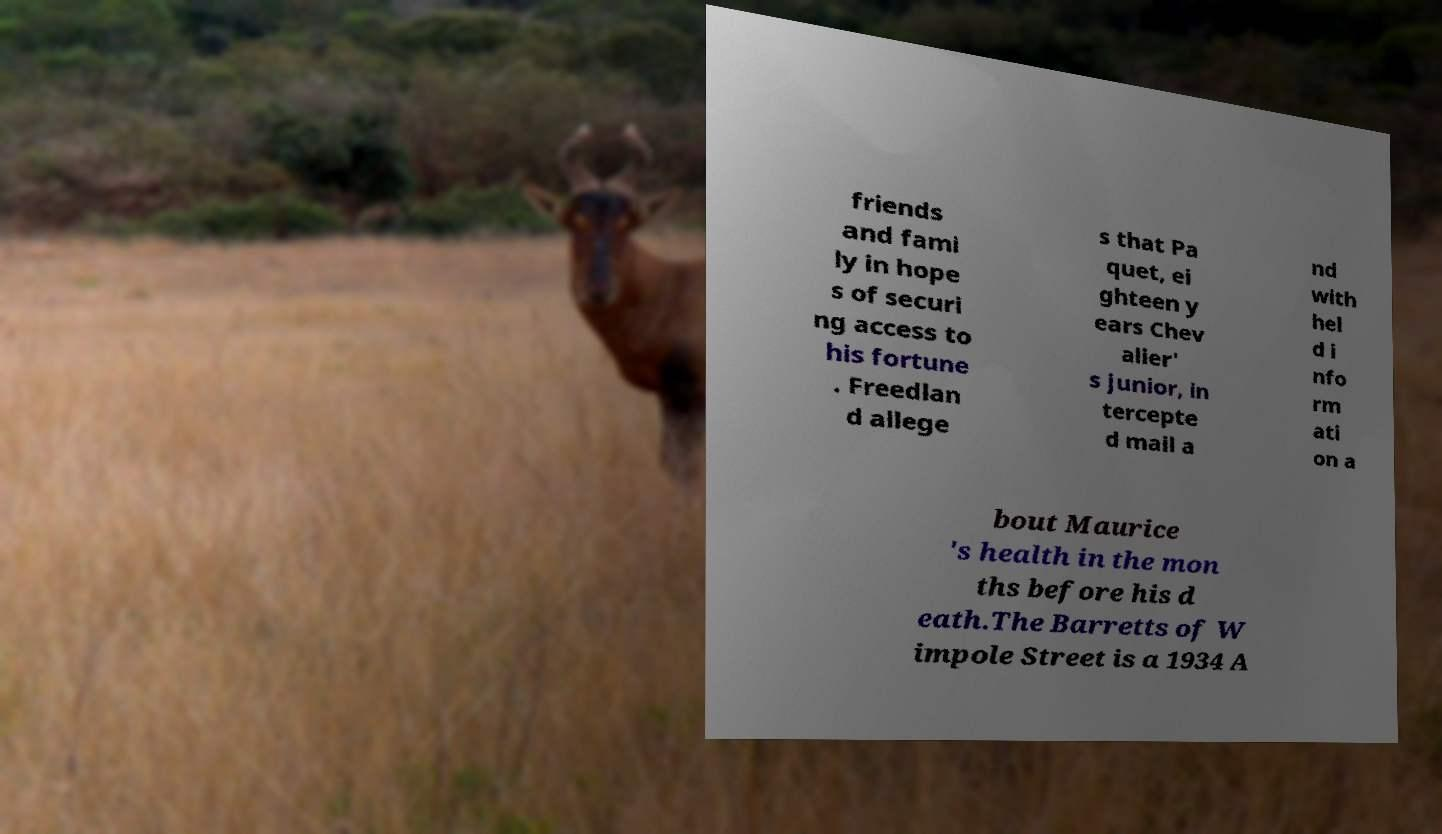Please read and relay the text visible in this image. What does it say? friends and fami ly in hope s of securi ng access to his fortune . Freedlan d allege s that Pa quet, ei ghteen y ears Chev alier' s junior, in tercepte d mail a nd with hel d i nfo rm ati on a bout Maurice 's health in the mon ths before his d eath.The Barretts of W impole Street is a 1934 A 